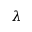<formula> <loc_0><loc_0><loc_500><loc_500>\lambda</formula> 